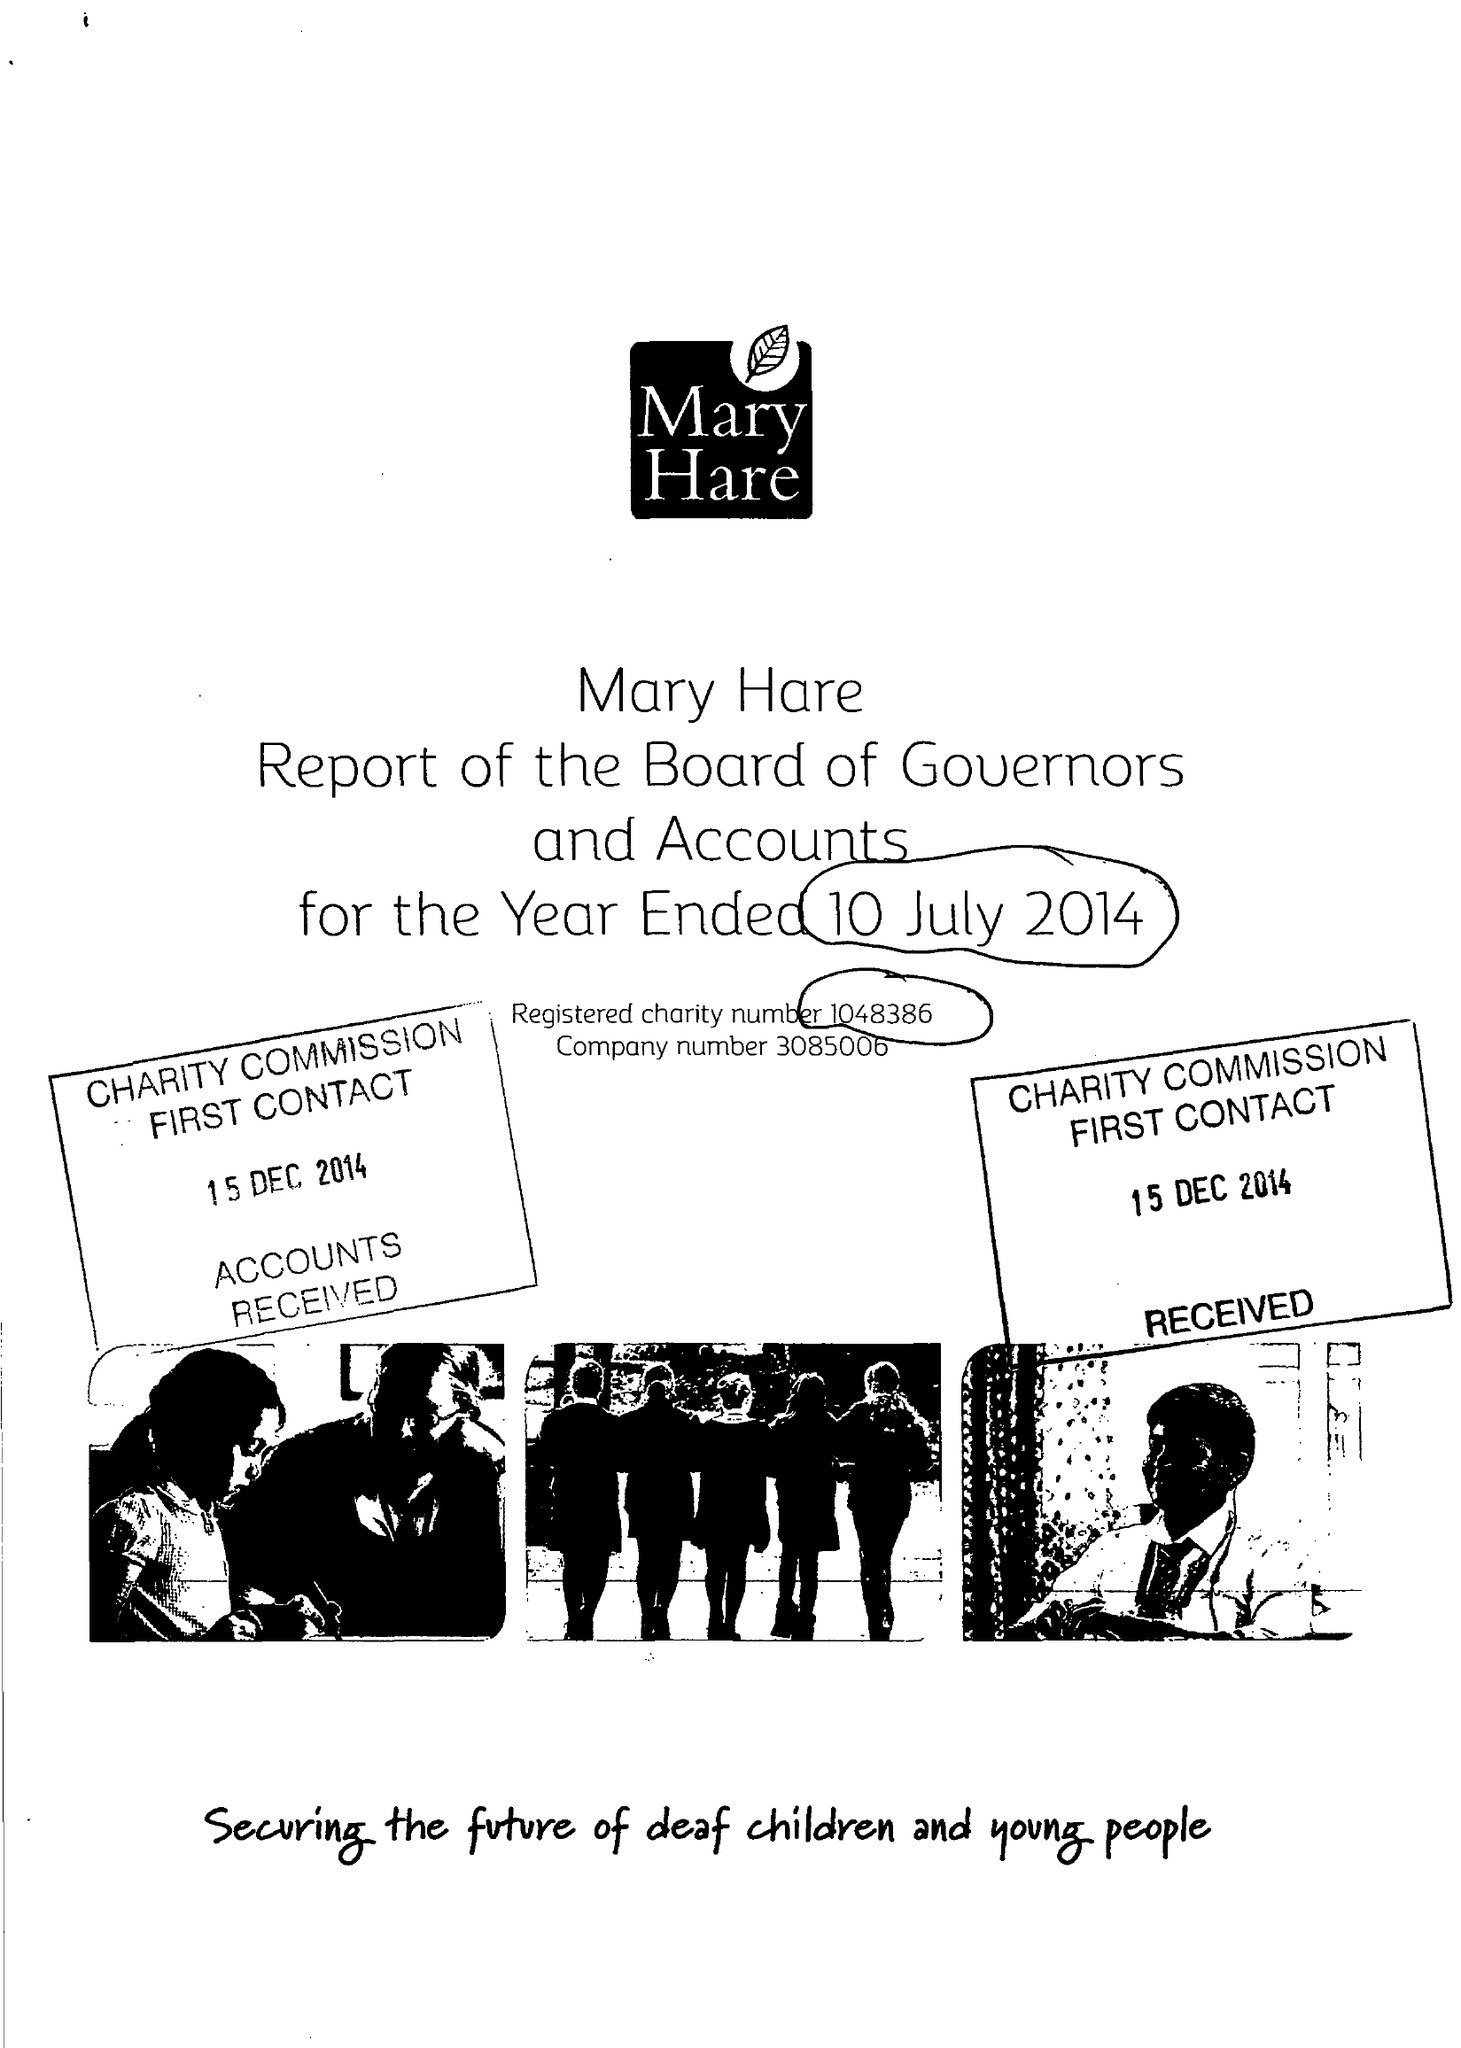What is the value for the charity_name?
Answer the question using a single word or phrase. Mary Hare 